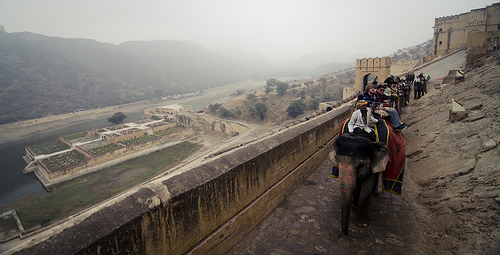Please provide the bounding box coordinate of the region this sentence describes: trees and shrubs on land. Coordinates [0.47, 0.4, 0.62, 0.47] outline an area rich with dense greenery, possibly indigenous shrubs and trees, contributing to the area’s ecological richness. 